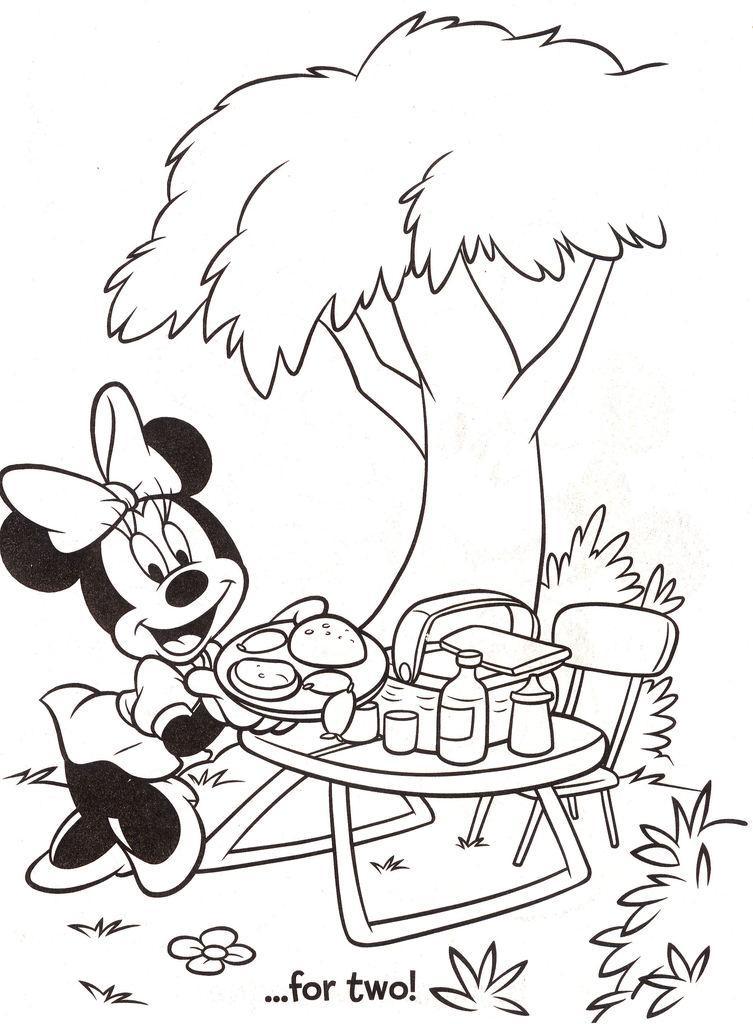Could you give a brief overview of what you see in this image? In this image we can see the sketch of a Mickey mouse, one big tree, plants, flower, one plate with food, one chair, some objects on the table, some grass and text on the bottom of the image. 